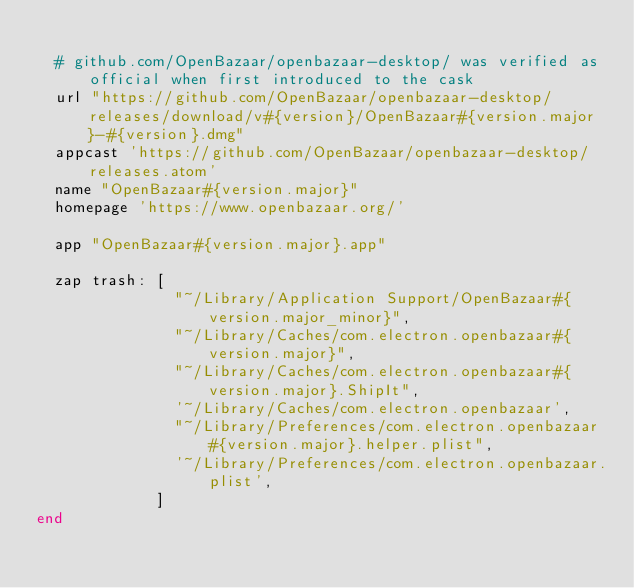<code> <loc_0><loc_0><loc_500><loc_500><_Ruby_>
  # github.com/OpenBazaar/openbazaar-desktop/ was verified as official when first introduced to the cask
  url "https://github.com/OpenBazaar/openbazaar-desktop/releases/download/v#{version}/OpenBazaar#{version.major}-#{version}.dmg"
  appcast 'https://github.com/OpenBazaar/openbazaar-desktop/releases.atom'
  name "OpenBazaar#{version.major}"
  homepage 'https://www.openbazaar.org/'

  app "OpenBazaar#{version.major}.app"

  zap trash: [
               "~/Library/Application Support/OpenBazaar#{version.major_minor}",
               "~/Library/Caches/com.electron.openbazaar#{version.major}",
               "~/Library/Caches/com.electron.openbazaar#{version.major}.ShipIt",
               '~/Library/Caches/com.electron.openbazaar',
               "~/Library/Preferences/com.electron.openbazaar#{version.major}.helper.plist",
               '~/Library/Preferences/com.electron.openbazaar.plist',
             ]
end
</code> 